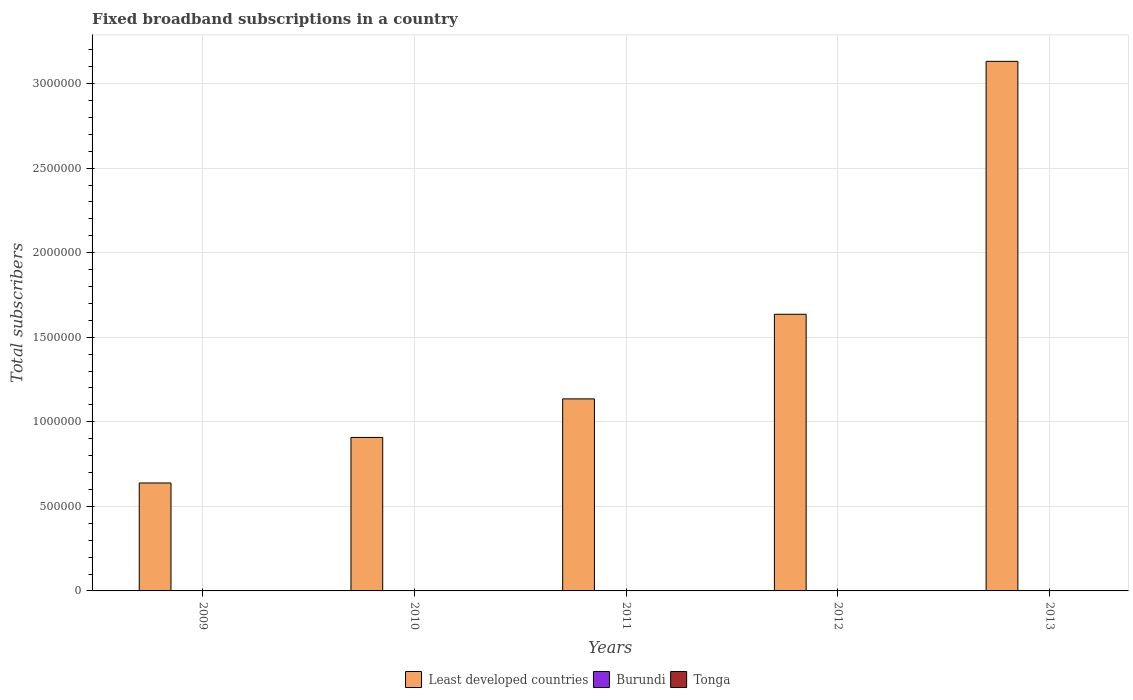How many groups of bars are there?
Offer a very short reply. 5. Are the number of bars per tick equal to the number of legend labels?
Keep it short and to the point. Yes. Are the number of bars on each tick of the X-axis equal?
Provide a succinct answer. Yes. How many bars are there on the 4th tick from the left?
Give a very brief answer. 3. How many bars are there on the 3rd tick from the right?
Your answer should be very brief. 3. What is the label of the 4th group of bars from the left?
Your response must be concise. 2012. In how many cases, is the number of bars for a given year not equal to the number of legend labels?
Ensure brevity in your answer.  0. What is the number of broadband subscriptions in Burundi in 2011?
Provide a succinct answer. 497. Across all years, what is the maximum number of broadband subscriptions in Burundi?
Offer a very short reply. 1534. Across all years, what is the minimum number of broadband subscriptions in Least developed countries?
Your answer should be very brief. 6.38e+05. What is the total number of broadband subscriptions in Least developed countries in the graph?
Your answer should be compact. 7.45e+06. What is the difference between the number of broadband subscriptions in Tonga in 2012 and that in 2013?
Offer a terse response. -200. What is the difference between the number of broadband subscriptions in Burundi in 2011 and the number of broadband subscriptions in Tonga in 2010?
Make the answer very short. -603. What is the average number of broadband subscriptions in Least developed countries per year?
Your answer should be very brief. 1.49e+06. In the year 2009, what is the difference between the number of broadband subscriptions in Burundi and number of broadband subscriptions in Least developed countries?
Provide a succinct answer. -6.38e+05. In how many years, is the number of broadband subscriptions in Tonga greater than 1300000?
Provide a succinct answer. 0. What is the ratio of the number of broadband subscriptions in Least developed countries in 2009 to that in 2011?
Keep it short and to the point. 0.56. Is the difference between the number of broadband subscriptions in Burundi in 2009 and 2010 greater than the difference between the number of broadband subscriptions in Least developed countries in 2009 and 2010?
Keep it short and to the point. Yes. What is the difference between the highest and the lowest number of broadband subscriptions in Tonga?
Give a very brief answer. 700. Is the sum of the number of broadband subscriptions in Burundi in 2011 and 2013 greater than the maximum number of broadband subscriptions in Least developed countries across all years?
Make the answer very short. No. What does the 1st bar from the left in 2010 represents?
Ensure brevity in your answer.  Least developed countries. What does the 2nd bar from the right in 2011 represents?
Offer a very short reply. Burundi. Is it the case that in every year, the sum of the number of broadband subscriptions in Tonga and number of broadband subscriptions in Least developed countries is greater than the number of broadband subscriptions in Burundi?
Your response must be concise. Yes. How many bars are there?
Your answer should be very brief. 15. Are all the bars in the graph horizontal?
Offer a very short reply. No. How many years are there in the graph?
Your answer should be compact. 5. What is the title of the graph?
Provide a short and direct response. Fixed broadband subscriptions in a country. What is the label or title of the X-axis?
Your response must be concise. Years. What is the label or title of the Y-axis?
Offer a terse response. Total subscribers. What is the Total subscribers of Least developed countries in 2009?
Offer a terse response. 6.38e+05. What is the Total subscribers in Burundi in 2009?
Ensure brevity in your answer.  160. What is the Total subscribers of Least developed countries in 2010?
Make the answer very short. 9.08e+05. What is the Total subscribers of Burundi in 2010?
Offer a very short reply. 352. What is the Total subscribers of Tonga in 2010?
Ensure brevity in your answer.  1100. What is the Total subscribers in Least developed countries in 2011?
Make the answer very short. 1.14e+06. What is the Total subscribers in Burundi in 2011?
Make the answer very short. 497. What is the Total subscribers of Tonga in 2011?
Provide a short and direct response. 1300. What is the Total subscribers of Least developed countries in 2012?
Your response must be concise. 1.64e+06. What is the Total subscribers in Burundi in 2012?
Provide a succinct answer. 702. What is the Total subscribers of Tonga in 2012?
Provide a short and direct response. 1500. What is the Total subscribers of Least developed countries in 2013?
Your response must be concise. 3.13e+06. What is the Total subscribers in Burundi in 2013?
Provide a short and direct response. 1534. What is the Total subscribers of Tonga in 2013?
Keep it short and to the point. 1700. Across all years, what is the maximum Total subscribers of Least developed countries?
Offer a terse response. 3.13e+06. Across all years, what is the maximum Total subscribers of Burundi?
Your answer should be very brief. 1534. Across all years, what is the maximum Total subscribers in Tonga?
Your answer should be very brief. 1700. Across all years, what is the minimum Total subscribers in Least developed countries?
Ensure brevity in your answer.  6.38e+05. Across all years, what is the minimum Total subscribers of Burundi?
Provide a succinct answer. 160. What is the total Total subscribers of Least developed countries in the graph?
Offer a very short reply. 7.45e+06. What is the total Total subscribers of Burundi in the graph?
Ensure brevity in your answer.  3245. What is the total Total subscribers in Tonga in the graph?
Offer a very short reply. 6600. What is the difference between the Total subscribers in Least developed countries in 2009 and that in 2010?
Provide a short and direct response. -2.69e+05. What is the difference between the Total subscribers in Burundi in 2009 and that in 2010?
Make the answer very short. -192. What is the difference between the Total subscribers in Tonga in 2009 and that in 2010?
Provide a succinct answer. -100. What is the difference between the Total subscribers in Least developed countries in 2009 and that in 2011?
Give a very brief answer. -4.97e+05. What is the difference between the Total subscribers in Burundi in 2009 and that in 2011?
Give a very brief answer. -337. What is the difference between the Total subscribers in Tonga in 2009 and that in 2011?
Your answer should be compact. -300. What is the difference between the Total subscribers of Least developed countries in 2009 and that in 2012?
Your response must be concise. -9.98e+05. What is the difference between the Total subscribers of Burundi in 2009 and that in 2012?
Ensure brevity in your answer.  -542. What is the difference between the Total subscribers in Tonga in 2009 and that in 2012?
Offer a terse response. -500. What is the difference between the Total subscribers of Least developed countries in 2009 and that in 2013?
Your response must be concise. -2.49e+06. What is the difference between the Total subscribers of Burundi in 2009 and that in 2013?
Give a very brief answer. -1374. What is the difference between the Total subscribers of Tonga in 2009 and that in 2013?
Your response must be concise. -700. What is the difference between the Total subscribers of Least developed countries in 2010 and that in 2011?
Keep it short and to the point. -2.28e+05. What is the difference between the Total subscribers in Burundi in 2010 and that in 2011?
Ensure brevity in your answer.  -145. What is the difference between the Total subscribers of Tonga in 2010 and that in 2011?
Your response must be concise. -200. What is the difference between the Total subscribers of Least developed countries in 2010 and that in 2012?
Make the answer very short. -7.28e+05. What is the difference between the Total subscribers of Burundi in 2010 and that in 2012?
Provide a short and direct response. -350. What is the difference between the Total subscribers in Tonga in 2010 and that in 2012?
Give a very brief answer. -400. What is the difference between the Total subscribers in Least developed countries in 2010 and that in 2013?
Make the answer very short. -2.22e+06. What is the difference between the Total subscribers in Burundi in 2010 and that in 2013?
Ensure brevity in your answer.  -1182. What is the difference between the Total subscribers of Tonga in 2010 and that in 2013?
Keep it short and to the point. -600. What is the difference between the Total subscribers of Least developed countries in 2011 and that in 2012?
Your response must be concise. -5.00e+05. What is the difference between the Total subscribers of Burundi in 2011 and that in 2012?
Keep it short and to the point. -205. What is the difference between the Total subscribers of Tonga in 2011 and that in 2012?
Provide a succinct answer. -200. What is the difference between the Total subscribers of Least developed countries in 2011 and that in 2013?
Make the answer very short. -2.00e+06. What is the difference between the Total subscribers in Burundi in 2011 and that in 2013?
Offer a terse response. -1037. What is the difference between the Total subscribers in Tonga in 2011 and that in 2013?
Your answer should be very brief. -400. What is the difference between the Total subscribers in Least developed countries in 2012 and that in 2013?
Your answer should be compact. -1.50e+06. What is the difference between the Total subscribers of Burundi in 2012 and that in 2013?
Provide a succinct answer. -832. What is the difference between the Total subscribers in Tonga in 2012 and that in 2013?
Provide a succinct answer. -200. What is the difference between the Total subscribers in Least developed countries in 2009 and the Total subscribers in Burundi in 2010?
Ensure brevity in your answer.  6.38e+05. What is the difference between the Total subscribers of Least developed countries in 2009 and the Total subscribers of Tonga in 2010?
Offer a very short reply. 6.37e+05. What is the difference between the Total subscribers in Burundi in 2009 and the Total subscribers in Tonga in 2010?
Your answer should be compact. -940. What is the difference between the Total subscribers in Least developed countries in 2009 and the Total subscribers in Burundi in 2011?
Offer a very short reply. 6.38e+05. What is the difference between the Total subscribers of Least developed countries in 2009 and the Total subscribers of Tonga in 2011?
Your answer should be very brief. 6.37e+05. What is the difference between the Total subscribers of Burundi in 2009 and the Total subscribers of Tonga in 2011?
Make the answer very short. -1140. What is the difference between the Total subscribers in Least developed countries in 2009 and the Total subscribers in Burundi in 2012?
Keep it short and to the point. 6.38e+05. What is the difference between the Total subscribers of Least developed countries in 2009 and the Total subscribers of Tonga in 2012?
Your answer should be compact. 6.37e+05. What is the difference between the Total subscribers in Burundi in 2009 and the Total subscribers in Tonga in 2012?
Your response must be concise. -1340. What is the difference between the Total subscribers of Least developed countries in 2009 and the Total subscribers of Burundi in 2013?
Give a very brief answer. 6.37e+05. What is the difference between the Total subscribers of Least developed countries in 2009 and the Total subscribers of Tonga in 2013?
Your answer should be very brief. 6.37e+05. What is the difference between the Total subscribers of Burundi in 2009 and the Total subscribers of Tonga in 2013?
Keep it short and to the point. -1540. What is the difference between the Total subscribers in Least developed countries in 2010 and the Total subscribers in Burundi in 2011?
Ensure brevity in your answer.  9.07e+05. What is the difference between the Total subscribers of Least developed countries in 2010 and the Total subscribers of Tonga in 2011?
Offer a terse response. 9.06e+05. What is the difference between the Total subscribers of Burundi in 2010 and the Total subscribers of Tonga in 2011?
Provide a succinct answer. -948. What is the difference between the Total subscribers of Least developed countries in 2010 and the Total subscribers of Burundi in 2012?
Your answer should be very brief. 9.07e+05. What is the difference between the Total subscribers in Least developed countries in 2010 and the Total subscribers in Tonga in 2012?
Your response must be concise. 9.06e+05. What is the difference between the Total subscribers of Burundi in 2010 and the Total subscribers of Tonga in 2012?
Your answer should be compact. -1148. What is the difference between the Total subscribers of Least developed countries in 2010 and the Total subscribers of Burundi in 2013?
Your answer should be compact. 9.06e+05. What is the difference between the Total subscribers of Least developed countries in 2010 and the Total subscribers of Tonga in 2013?
Your answer should be very brief. 9.06e+05. What is the difference between the Total subscribers in Burundi in 2010 and the Total subscribers in Tonga in 2013?
Your answer should be compact. -1348. What is the difference between the Total subscribers in Least developed countries in 2011 and the Total subscribers in Burundi in 2012?
Give a very brief answer. 1.13e+06. What is the difference between the Total subscribers of Least developed countries in 2011 and the Total subscribers of Tonga in 2012?
Provide a short and direct response. 1.13e+06. What is the difference between the Total subscribers of Burundi in 2011 and the Total subscribers of Tonga in 2012?
Your answer should be compact. -1003. What is the difference between the Total subscribers of Least developed countries in 2011 and the Total subscribers of Burundi in 2013?
Provide a succinct answer. 1.13e+06. What is the difference between the Total subscribers in Least developed countries in 2011 and the Total subscribers in Tonga in 2013?
Your answer should be very brief. 1.13e+06. What is the difference between the Total subscribers of Burundi in 2011 and the Total subscribers of Tonga in 2013?
Offer a very short reply. -1203. What is the difference between the Total subscribers in Least developed countries in 2012 and the Total subscribers in Burundi in 2013?
Your answer should be compact. 1.63e+06. What is the difference between the Total subscribers of Least developed countries in 2012 and the Total subscribers of Tonga in 2013?
Make the answer very short. 1.63e+06. What is the difference between the Total subscribers in Burundi in 2012 and the Total subscribers in Tonga in 2013?
Your answer should be compact. -998. What is the average Total subscribers of Least developed countries per year?
Provide a short and direct response. 1.49e+06. What is the average Total subscribers of Burundi per year?
Give a very brief answer. 649. What is the average Total subscribers of Tonga per year?
Keep it short and to the point. 1320. In the year 2009, what is the difference between the Total subscribers of Least developed countries and Total subscribers of Burundi?
Give a very brief answer. 6.38e+05. In the year 2009, what is the difference between the Total subscribers in Least developed countries and Total subscribers in Tonga?
Your answer should be compact. 6.37e+05. In the year 2009, what is the difference between the Total subscribers in Burundi and Total subscribers in Tonga?
Provide a succinct answer. -840. In the year 2010, what is the difference between the Total subscribers in Least developed countries and Total subscribers in Burundi?
Give a very brief answer. 9.07e+05. In the year 2010, what is the difference between the Total subscribers of Least developed countries and Total subscribers of Tonga?
Your response must be concise. 9.07e+05. In the year 2010, what is the difference between the Total subscribers in Burundi and Total subscribers in Tonga?
Offer a terse response. -748. In the year 2011, what is the difference between the Total subscribers of Least developed countries and Total subscribers of Burundi?
Your answer should be very brief. 1.14e+06. In the year 2011, what is the difference between the Total subscribers in Least developed countries and Total subscribers in Tonga?
Give a very brief answer. 1.13e+06. In the year 2011, what is the difference between the Total subscribers of Burundi and Total subscribers of Tonga?
Your response must be concise. -803. In the year 2012, what is the difference between the Total subscribers of Least developed countries and Total subscribers of Burundi?
Keep it short and to the point. 1.64e+06. In the year 2012, what is the difference between the Total subscribers in Least developed countries and Total subscribers in Tonga?
Your answer should be very brief. 1.63e+06. In the year 2012, what is the difference between the Total subscribers of Burundi and Total subscribers of Tonga?
Make the answer very short. -798. In the year 2013, what is the difference between the Total subscribers in Least developed countries and Total subscribers in Burundi?
Provide a short and direct response. 3.13e+06. In the year 2013, what is the difference between the Total subscribers in Least developed countries and Total subscribers in Tonga?
Ensure brevity in your answer.  3.13e+06. In the year 2013, what is the difference between the Total subscribers of Burundi and Total subscribers of Tonga?
Provide a short and direct response. -166. What is the ratio of the Total subscribers in Least developed countries in 2009 to that in 2010?
Give a very brief answer. 0.7. What is the ratio of the Total subscribers of Burundi in 2009 to that in 2010?
Ensure brevity in your answer.  0.45. What is the ratio of the Total subscribers in Least developed countries in 2009 to that in 2011?
Offer a very short reply. 0.56. What is the ratio of the Total subscribers in Burundi in 2009 to that in 2011?
Keep it short and to the point. 0.32. What is the ratio of the Total subscribers of Tonga in 2009 to that in 2011?
Your response must be concise. 0.77. What is the ratio of the Total subscribers in Least developed countries in 2009 to that in 2012?
Keep it short and to the point. 0.39. What is the ratio of the Total subscribers of Burundi in 2009 to that in 2012?
Provide a succinct answer. 0.23. What is the ratio of the Total subscribers in Least developed countries in 2009 to that in 2013?
Your answer should be compact. 0.2. What is the ratio of the Total subscribers in Burundi in 2009 to that in 2013?
Provide a short and direct response. 0.1. What is the ratio of the Total subscribers in Tonga in 2009 to that in 2013?
Give a very brief answer. 0.59. What is the ratio of the Total subscribers in Least developed countries in 2010 to that in 2011?
Your answer should be compact. 0.8. What is the ratio of the Total subscribers of Burundi in 2010 to that in 2011?
Provide a succinct answer. 0.71. What is the ratio of the Total subscribers of Tonga in 2010 to that in 2011?
Offer a terse response. 0.85. What is the ratio of the Total subscribers in Least developed countries in 2010 to that in 2012?
Keep it short and to the point. 0.55. What is the ratio of the Total subscribers of Burundi in 2010 to that in 2012?
Make the answer very short. 0.5. What is the ratio of the Total subscribers in Tonga in 2010 to that in 2012?
Offer a terse response. 0.73. What is the ratio of the Total subscribers of Least developed countries in 2010 to that in 2013?
Your response must be concise. 0.29. What is the ratio of the Total subscribers of Burundi in 2010 to that in 2013?
Give a very brief answer. 0.23. What is the ratio of the Total subscribers in Tonga in 2010 to that in 2013?
Make the answer very short. 0.65. What is the ratio of the Total subscribers in Least developed countries in 2011 to that in 2012?
Offer a terse response. 0.69. What is the ratio of the Total subscribers of Burundi in 2011 to that in 2012?
Ensure brevity in your answer.  0.71. What is the ratio of the Total subscribers in Tonga in 2011 to that in 2012?
Your answer should be compact. 0.87. What is the ratio of the Total subscribers of Least developed countries in 2011 to that in 2013?
Offer a terse response. 0.36. What is the ratio of the Total subscribers in Burundi in 2011 to that in 2013?
Your response must be concise. 0.32. What is the ratio of the Total subscribers of Tonga in 2011 to that in 2013?
Offer a very short reply. 0.76. What is the ratio of the Total subscribers in Least developed countries in 2012 to that in 2013?
Provide a succinct answer. 0.52. What is the ratio of the Total subscribers of Burundi in 2012 to that in 2013?
Your answer should be compact. 0.46. What is the ratio of the Total subscribers in Tonga in 2012 to that in 2013?
Provide a succinct answer. 0.88. What is the difference between the highest and the second highest Total subscribers in Least developed countries?
Make the answer very short. 1.50e+06. What is the difference between the highest and the second highest Total subscribers of Burundi?
Offer a very short reply. 832. What is the difference between the highest and the lowest Total subscribers of Least developed countries?
Make the answer very short. 2.49e+06. What is the difference between the highest and the lowest Total subscribers of Burundi?
Offer a terse response. 1374. What is the difference between the highest and the lowest Total subscribers of Tonga?
Give a very brief answer. 700. 